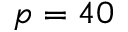Convert formula to latex. <formula><loc_0><loc_0><loc_500><loc_500>p = 4 0</formula> 